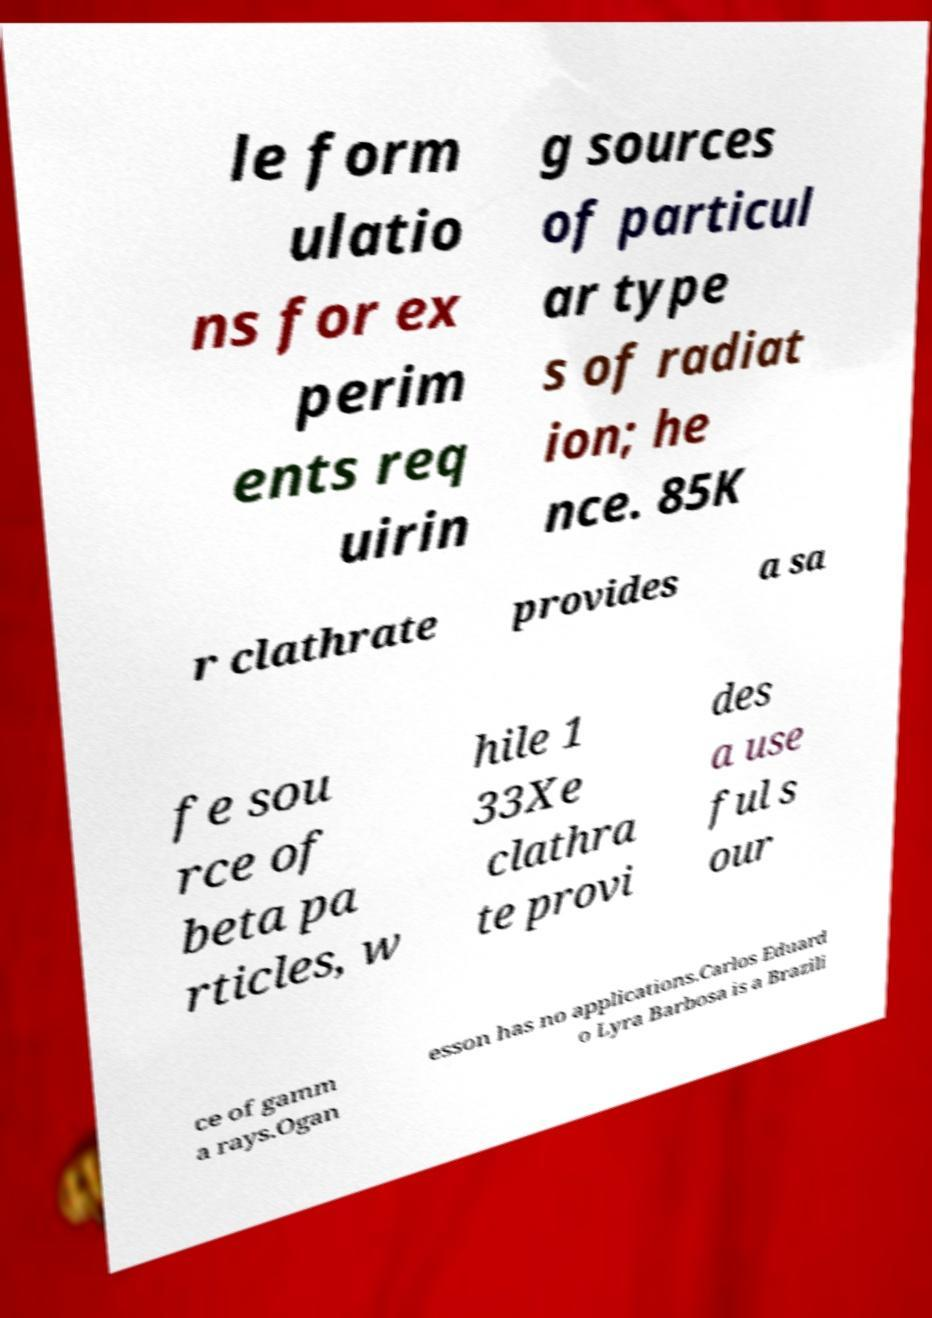Could you extract and type out the text from this image? le form ulatio ns for ex perim ents req uirin g sources of particul ar type s of radiat ion; he nce. 85K r clathrate provides a sa fe sou rce of beta pa rticles, w hile 1 33Xe clathra te provi des a use ful s our ce of gamm a rays.Ogan esson has no applications.Carlos Eduard o Lyra Barbosa is a Brazili 